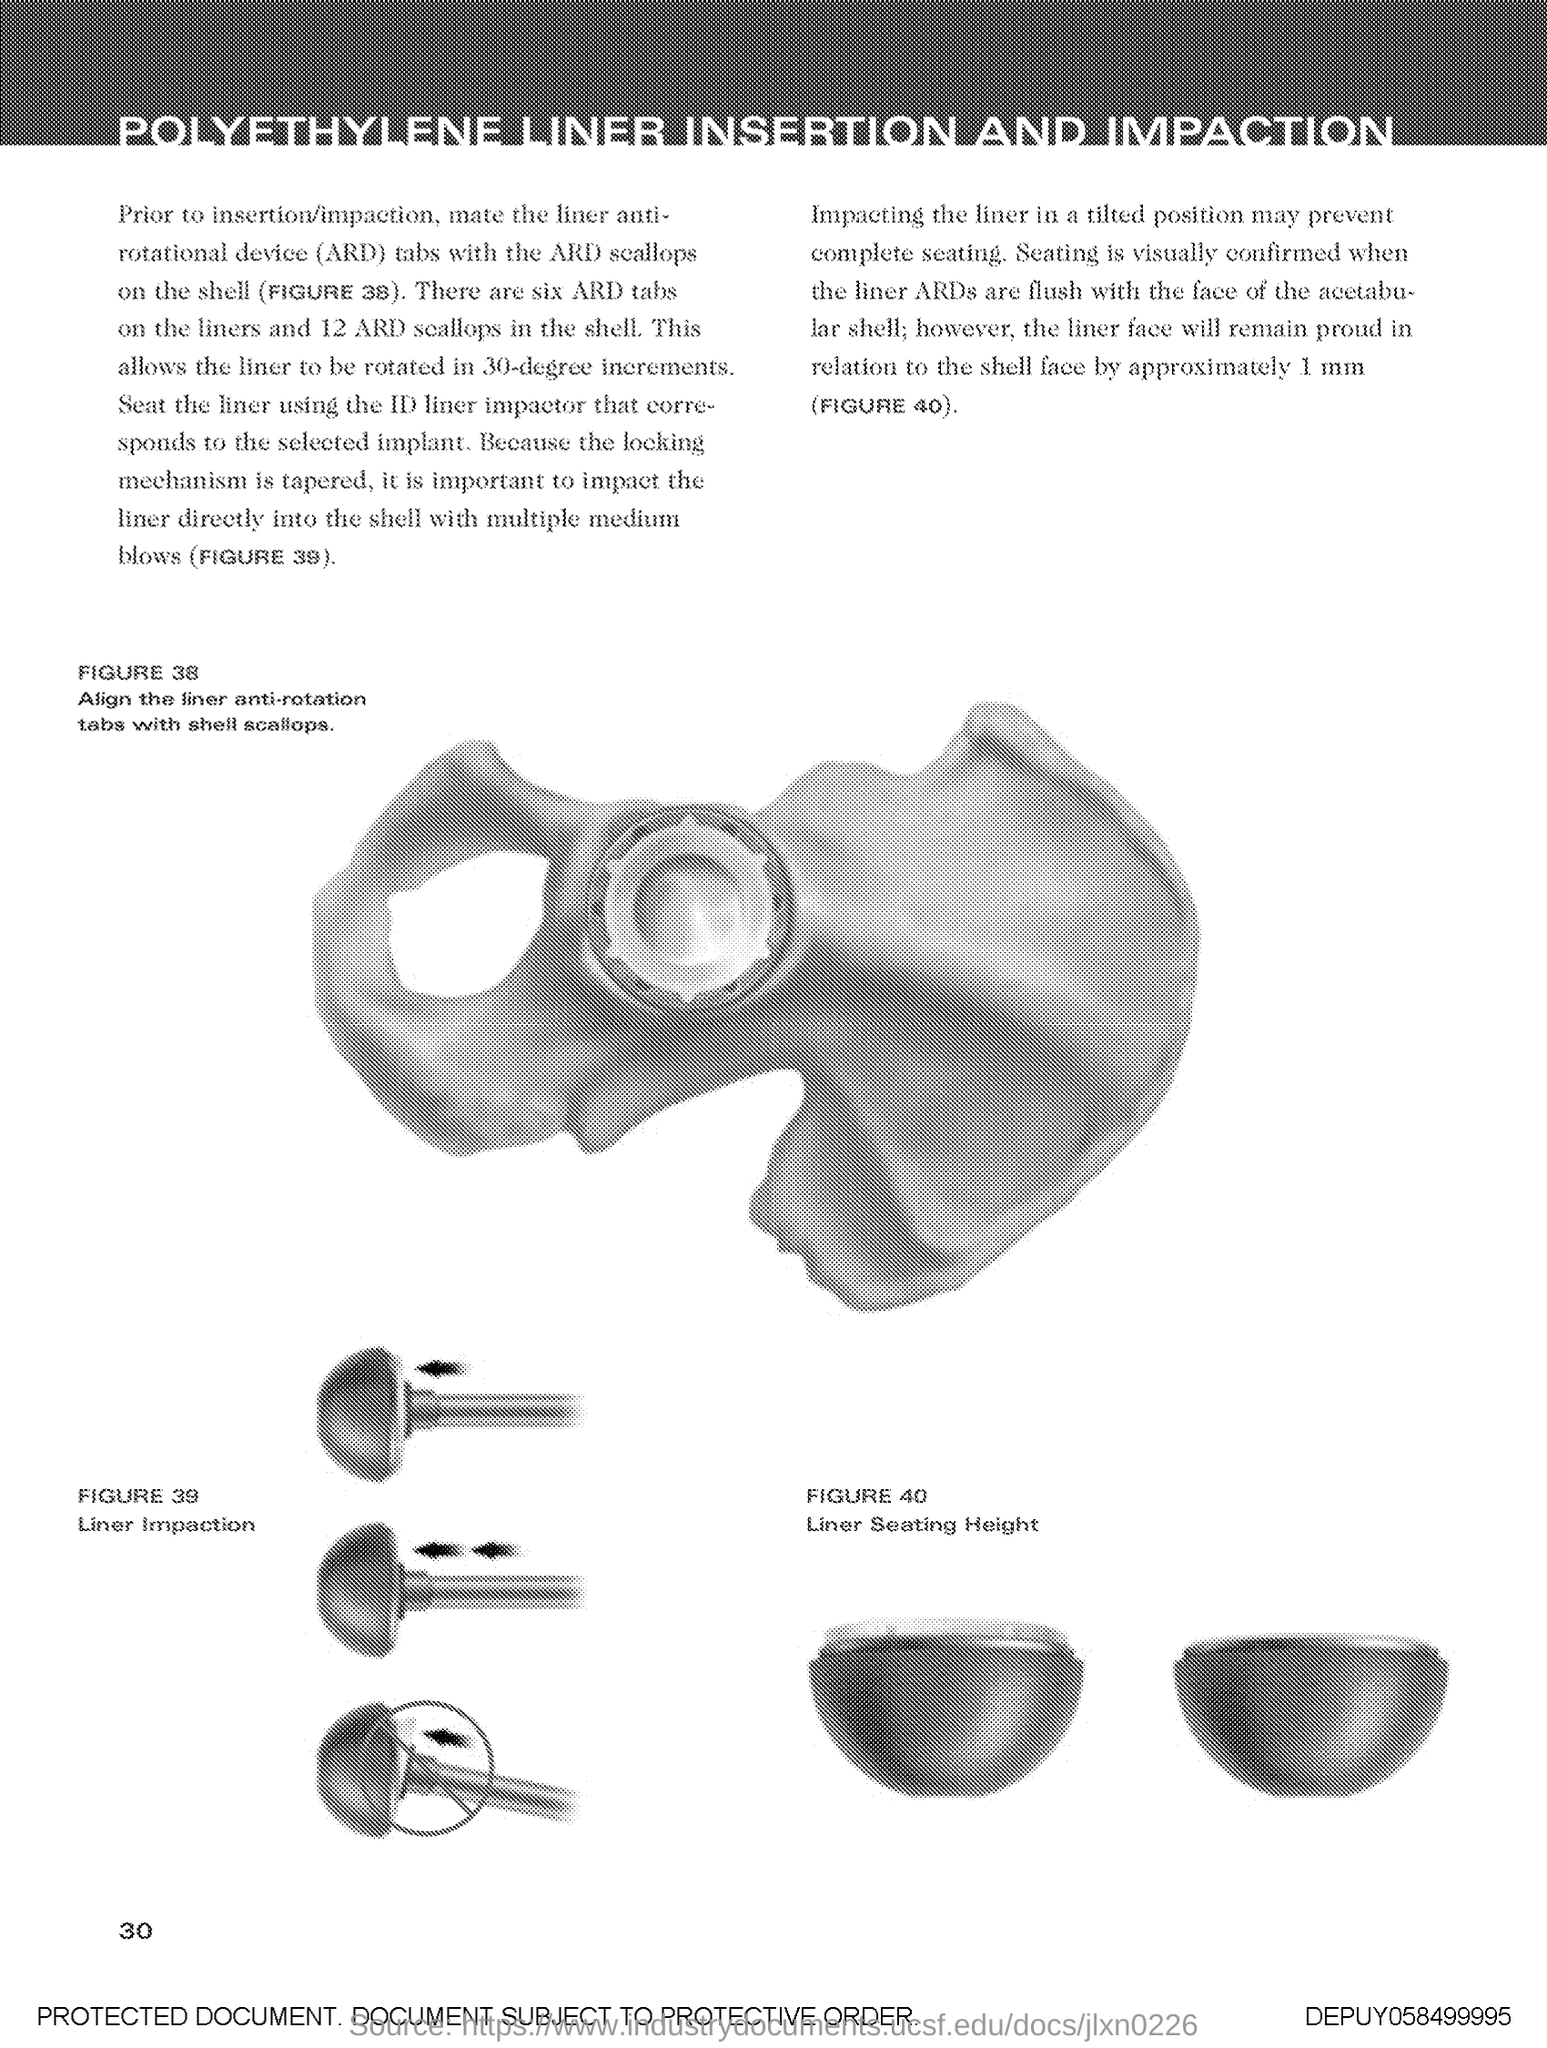Outline some significant characteristics in this image. The Page Number is 30. The title of the document is "Polyethylene Liner Insertion and Impaction. 